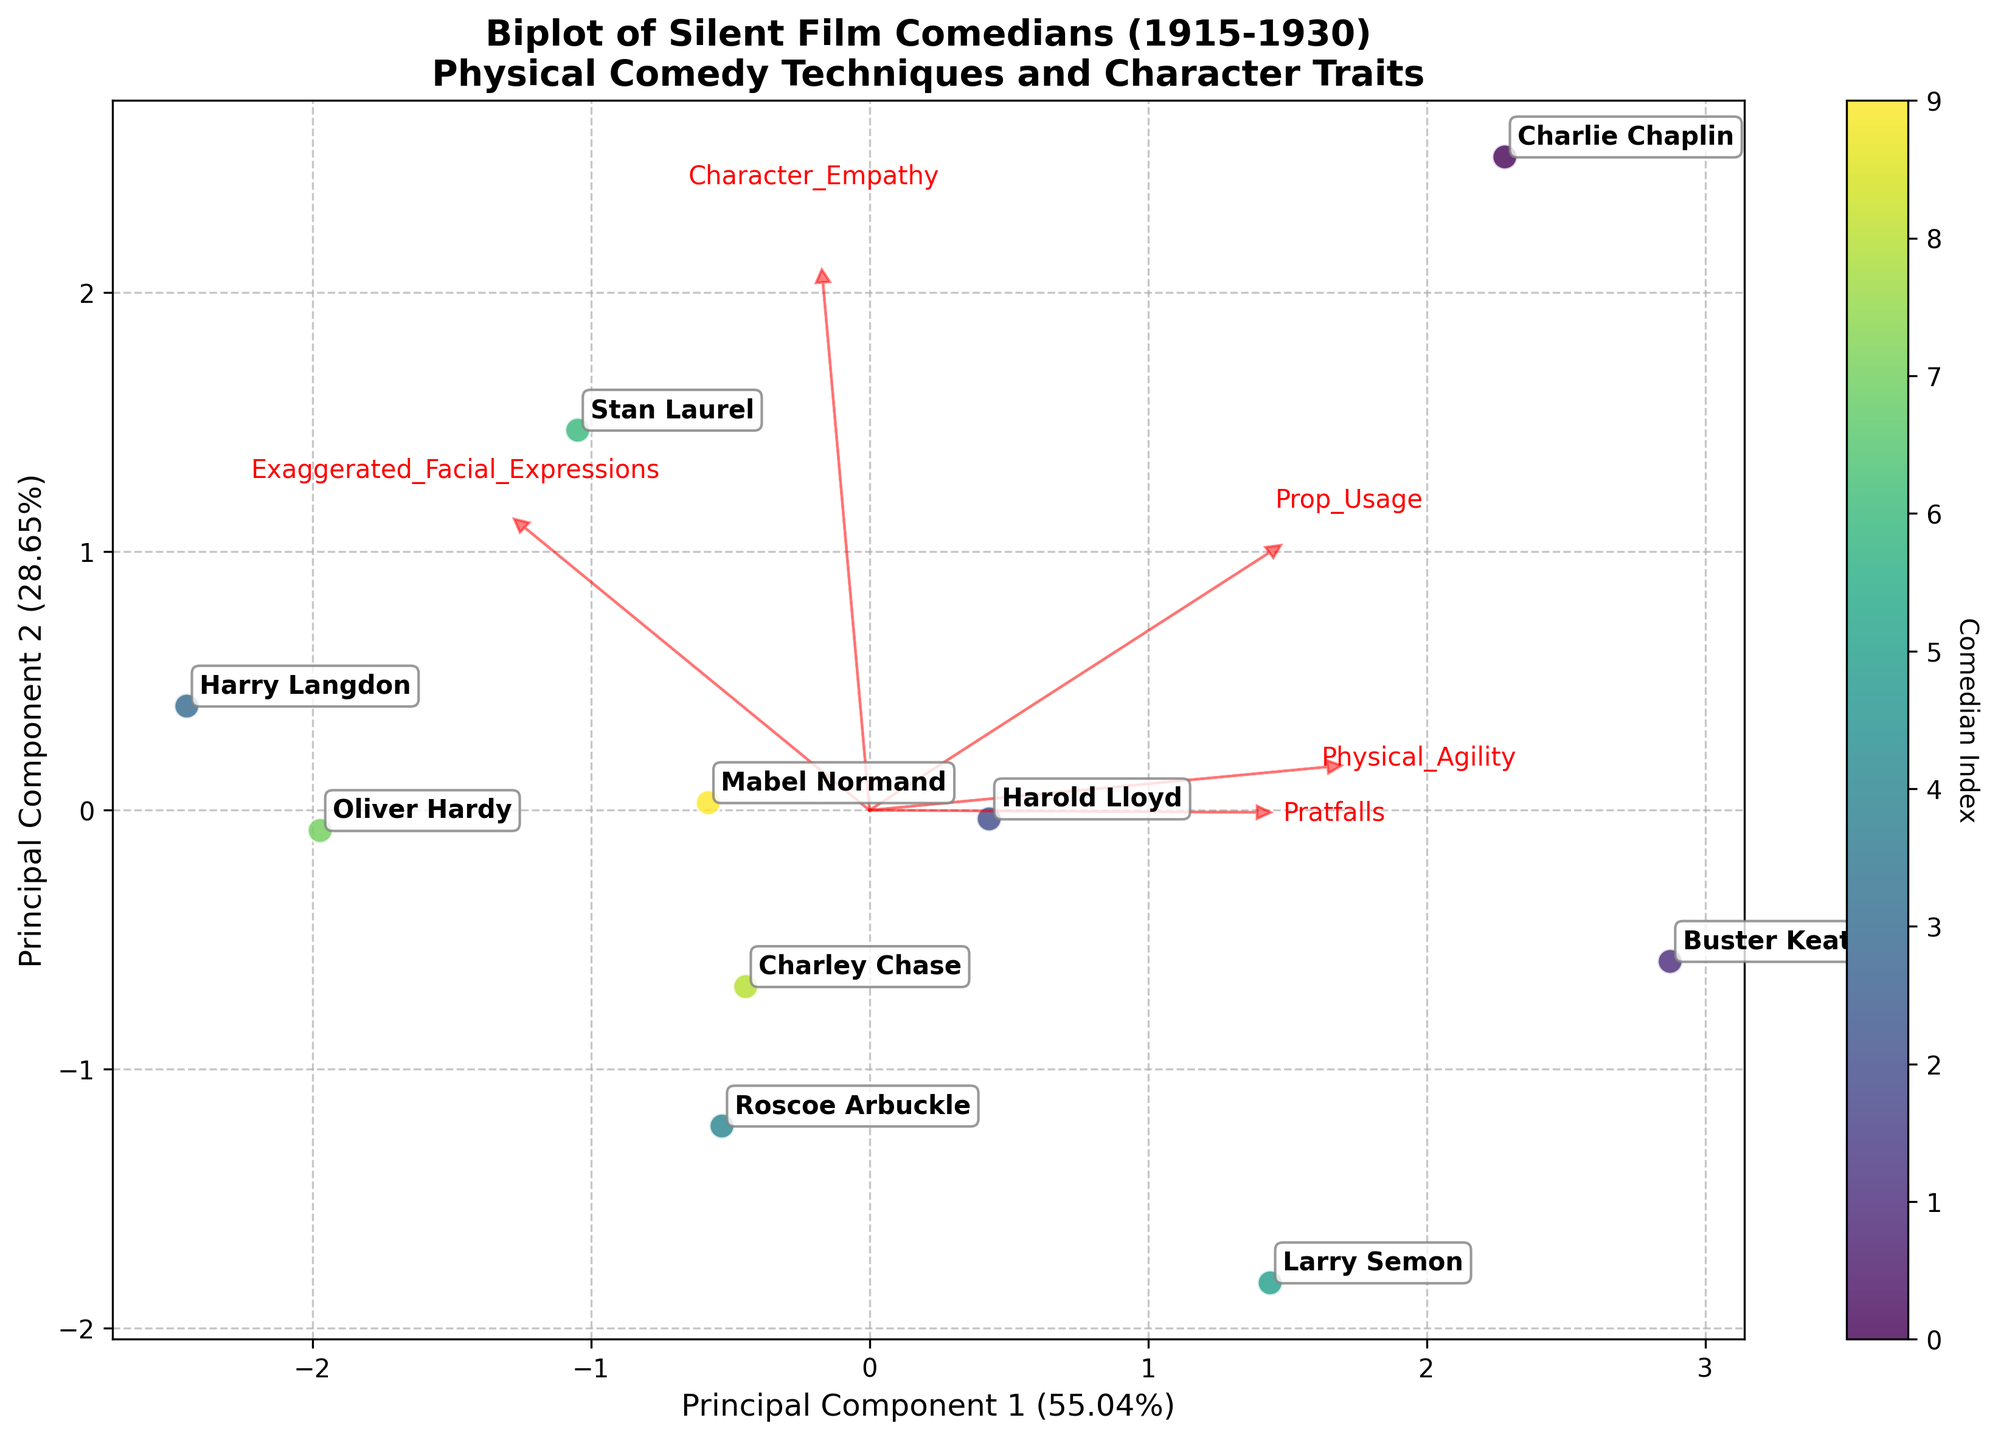What's the title of the biplot? The title is at the top of the figure and provides a summary of what the plot represents. It says "Biplot of Silent Film Comedians (1915-1930)\nPhysical Comedy Techniques and Character Traits".
Answer: Biplot of Silent Film Comedians (1915-1930) Physical Comedy Techniques and Character Traits Which comedian is closest to the center of the plot? The center of a PCA biplot is where both principal component values are zero. By observing the scatter plot, it appears that Roscoe Arbuckle is closest to the center.
Answer: Roscoe Arbuckle What are the principal components' axes labeled as? The principal component axes labels convey information about the variance explained by each principal component. They are labeled "Principal Component 1" and "Principal Component 2" with corresponding variance percentages.
Answer: Principal Component 1 and Principal Component 2 Which feature has the largest influence on Principal Component 1? The feature with the largest influence on Principal Component 1 will have the longest arrow projecting in the horizontal direction. Observing the plot, "Prop_Usage" seems to have the longest horizontal arrow.
Answer: Prop Usage Which comedian has the highest score on Principal Component 2? By identifying the placement of each comedian along the vertical axis and finding the one highest up, it appears that Harry Langdon has the highest score on Principal Component 2.
Answer: Harry Langdon Which comedians are positioned furthest apart on the biplot? To determine which comedians are furthest apart, look for the largest distance between data points. Charlie Chaplin and Harry Langdon are positioned far apart.
Answer: Charlie Chaplin and Harry Langdon What is the relationship between "Physical Agility" and "Character Empathy"? The biplot shows arrows that represent features. If "Physical Agility" and "Character Empathy" arrows point in roughly the same direction, they are positively correlated. By observing, these two arrows are somewhat aligned, indicating a positive relationship.
Answer: Positively correlated Which comedians utilize pratfalls more intensely than others? The length and direction of the "Pratfalls" arrow can help identify which comedians score high. Comedians positioned in the direction of this arrow include Charlie Chaplin and Larry Semon, indicating extensive pratfall usage.
Answer: Charlie Chaplin and Larry Semon How many principal components are depicted in the biplot? PCA biplots typically show two principal components for visualization purposes. Here, two components are displayed, as indicated by the axes labeled Principal Component 1 and Principal Component 2.
Answer: Two What variance percentage is explained by the first principal component? The variance percentage explained by the first principal component is shown alongside its label on the x-axis. It is represented as a percentage.
Answer: (Percentage on x-axis label) 